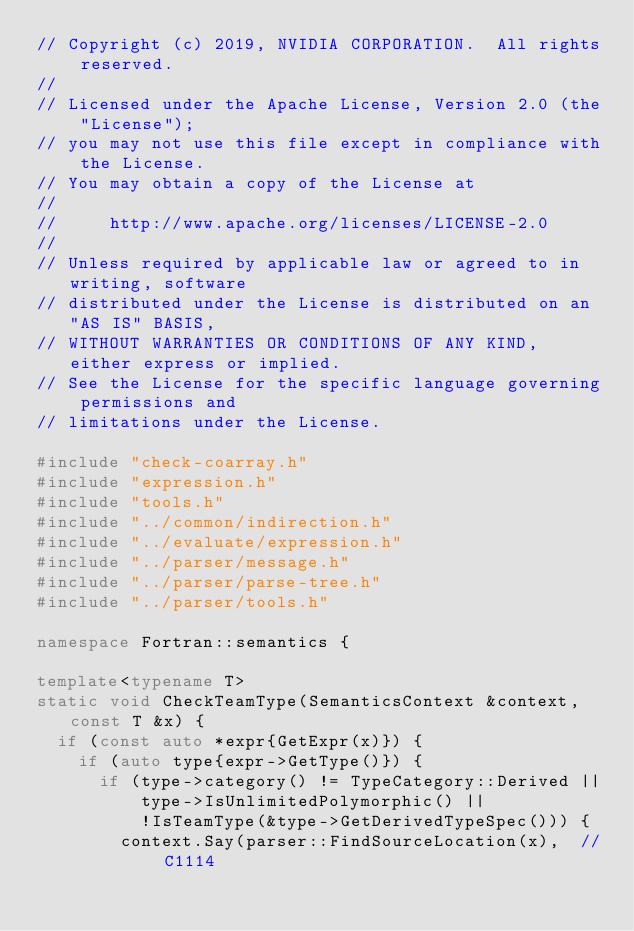Convert code to text. <code><loc_0><loc_0><loc_500><loc_500><_C++_>// Copyright (c) 2019, NVIDIA CORPORATION.  All rights reserved.
//
// Licensed under the Apache License, Version 2.0 (the "License");
// you may not use this file except in compliance with the License.
// You may obtain a copy of the License at
//
//     http://www.apache.org/licenses/LICENSE-2.0
//
// Unless required by applicable law or agreed to in writing, software
// distributed under the License is distributed on an "AS IS" BASIS,
// WITHOUT WARRANTIES OR CONDITIONS OF ANY KIND, either express or implied.
// See the License for the specific language governing permissions and
// limitations under the License.

#include "check-coarray.h"
#include "expression.h"
#include "tools.h"
#include "../common/indirection.h"
#include "../evaluate/expression.h"
#include "../parser/message.h"
#include "../parser/parse-tree.h"
#include "../parser/tools.h"

namespace Fortran::semantics {

template<typename T>
static void CheckTeamType(SemanticsContext &context, const T &x) {
  if (const auto *expr{GetExpr(x)}) {
    if (auto type{expr->GetType()}) {
      if (type->category() != TypeCategory::Derived ||
          type->IsUnlimitedPolymorphic() ||
          !IsTeamType(&type->GetDerivedTypeSpec())) {
        context.Say(parser::FindSourceLocation(x),  // C1114</code> 